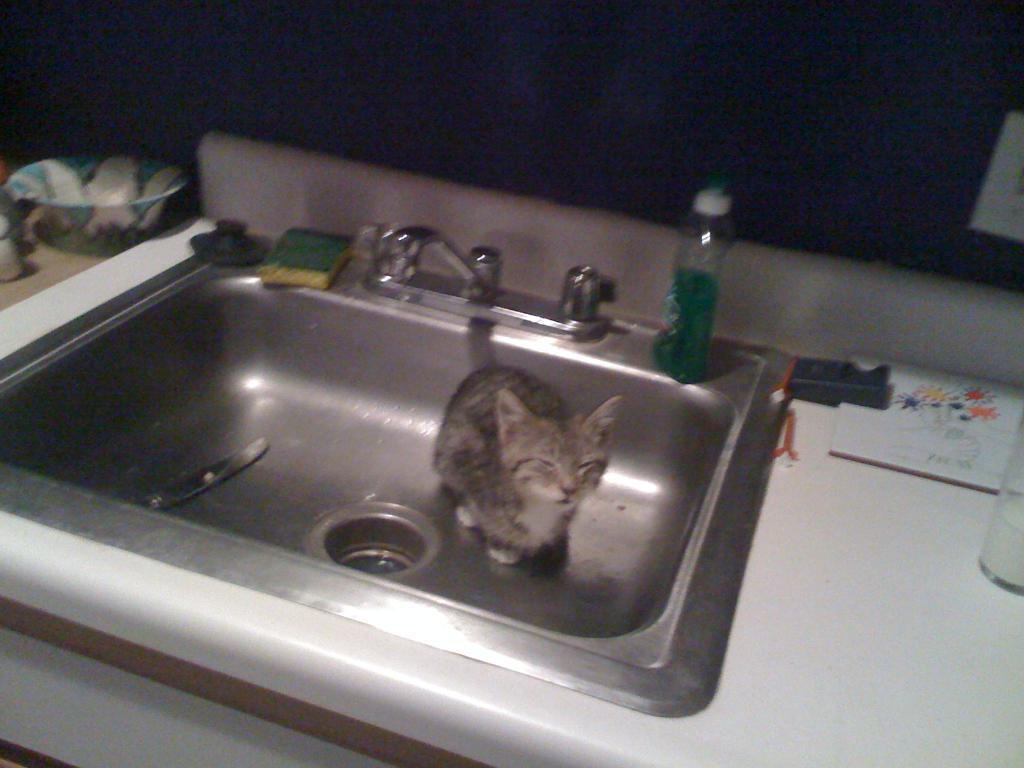What animal can be seen in the sink in the image? There is a cat in the sink. What is located above the sink? There is a tap on top of the sink. What items are on top of the sink? There is a bottle and a scrub pad on top of the sink. What is beside the sink? There is a bowl beside the sink. What is on the right side of the sink? There is a glass on the right side of the sink. Can you see the cat's wrist in the image? There is no mention of a cat's wrist in the image, and it is not visible. What type of toad is sitting on the glass in the image? There is no toad present in the image; it only features a cat, sink, tap, bottle, scrub pad, bowl, and glass. 